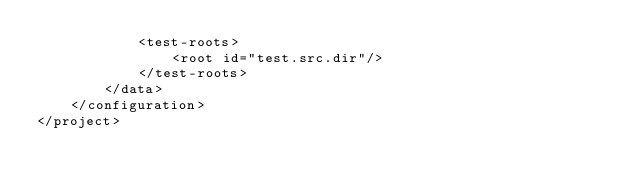Convert code to text. <code><loc_0><loc_0><loc_500><loc_500><_XML_>            <test-roots>
                <root id="test.src.dir"/>
            </test-roots>
        </data>
    </configuration>
</project>
</code> 